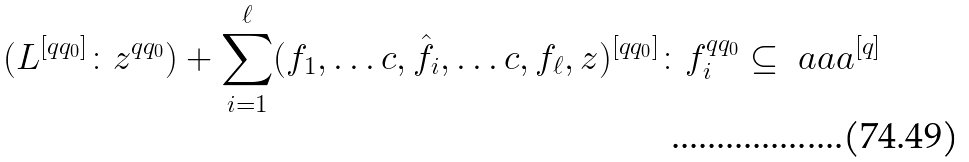<formula> <loc_0><loc_0><loc_500><loc_500>( L ^ { [ q q _ { 0 } ] } \colon z ^ { q q _ { 0 } } ) + \sum _ { i = 1 } ^ { \ell } ( f _ { 1 } , \dots c , \hat { f _ { i } } , \dots c , f _ { \ell } , z ) ^ { [ q q _ { 0 } ] } \colon f _ { i } ^ { q q _ { 0 } } \subseteq \ a a a ^ { [ q ] }</formula> 